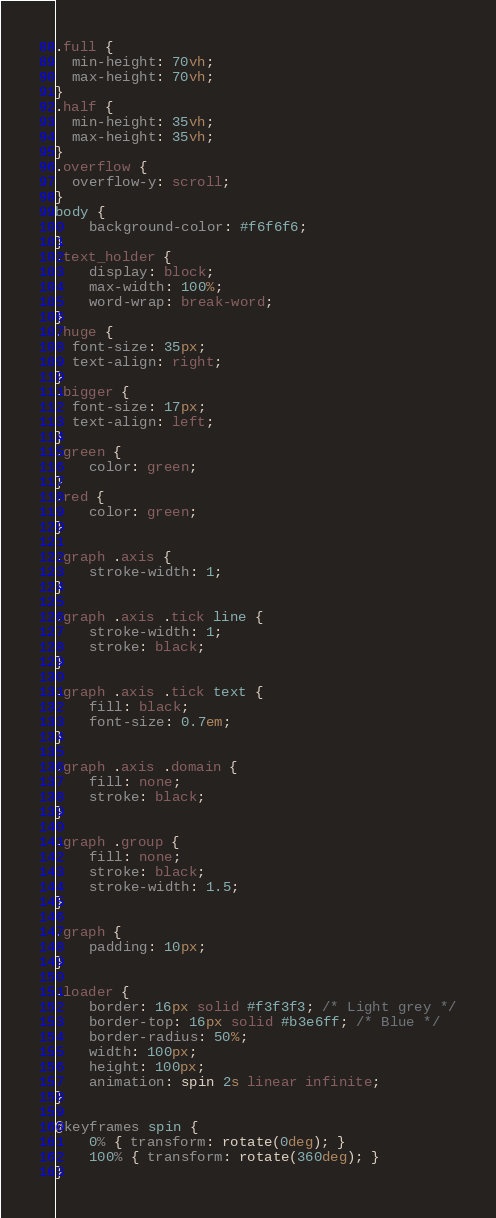Convert code to text. <code><loc_0><loc_0><loc_500><loc_500><_CSS_>.full {
  min-height: 70vh;
  max-height: 70vh;
}
.half {
  min-height: 35vh;
  max-height: 35vh;
}
.overflow {
  overflow-y: scroll;
}
body {
    background-color: #f6f6f6;
}
.text_holder {
    display: block;
    max-width: 100%;
    word-wrap: break-word;
}
.huge {
  font-size: 35px;
  text-align: right;
}
.bigger {
  font-size: 17px;
  text-align: left;
}
.green {
    color: green;
}
.red {
    color: green;
}

.graph .axis {
    stroke-width: 1;
}

.graph .axis .tick line {
    stroke-width: 1;
    stroke: black;
}

.graph .axis .tick text {
    fill: black;
    font-size: 0.7em;
}

.graph .axis .domain {
    fill: none;
    stroke: black;
}

.graph .group {
    fill: none;
    stroke: black;
    stroke-width: 1.5;
}

.graph {
    padding: 10px;
}

.loader {
    border: 16px solid #f3f3f3; /* Light grey */
    border-top: 16px solid #b3e6ff; /* Blue */
    border-radius: 50%;
    width: 100px;
    height: 100px;
    animation: spin 2s linear infinite;
}

@keyframes spin {
    0% { transform: rotate(0deg); }
    100% { transform: rotate(360deg); }
}
</code> 